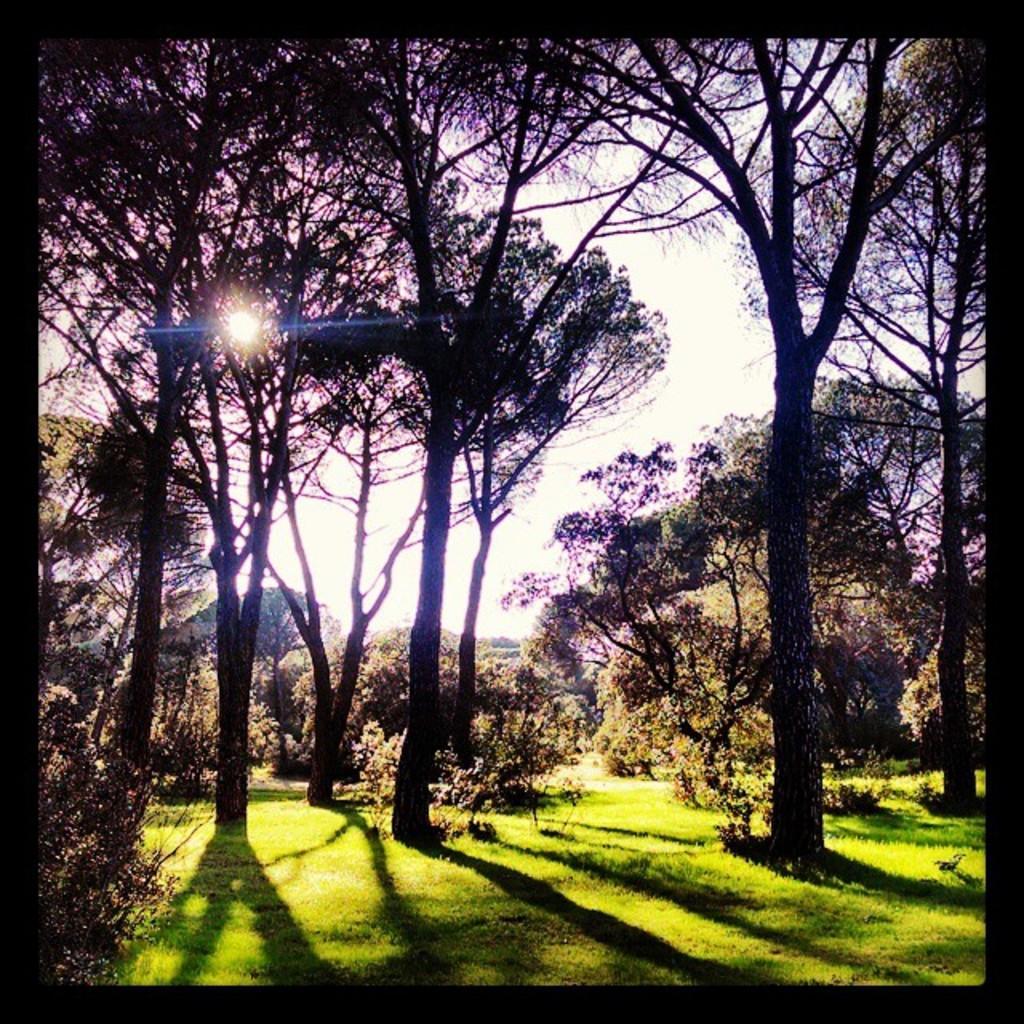Please provide a concise description of this image. In this image there are some trees, and at the bottom there is grass and in the background there is sky. 